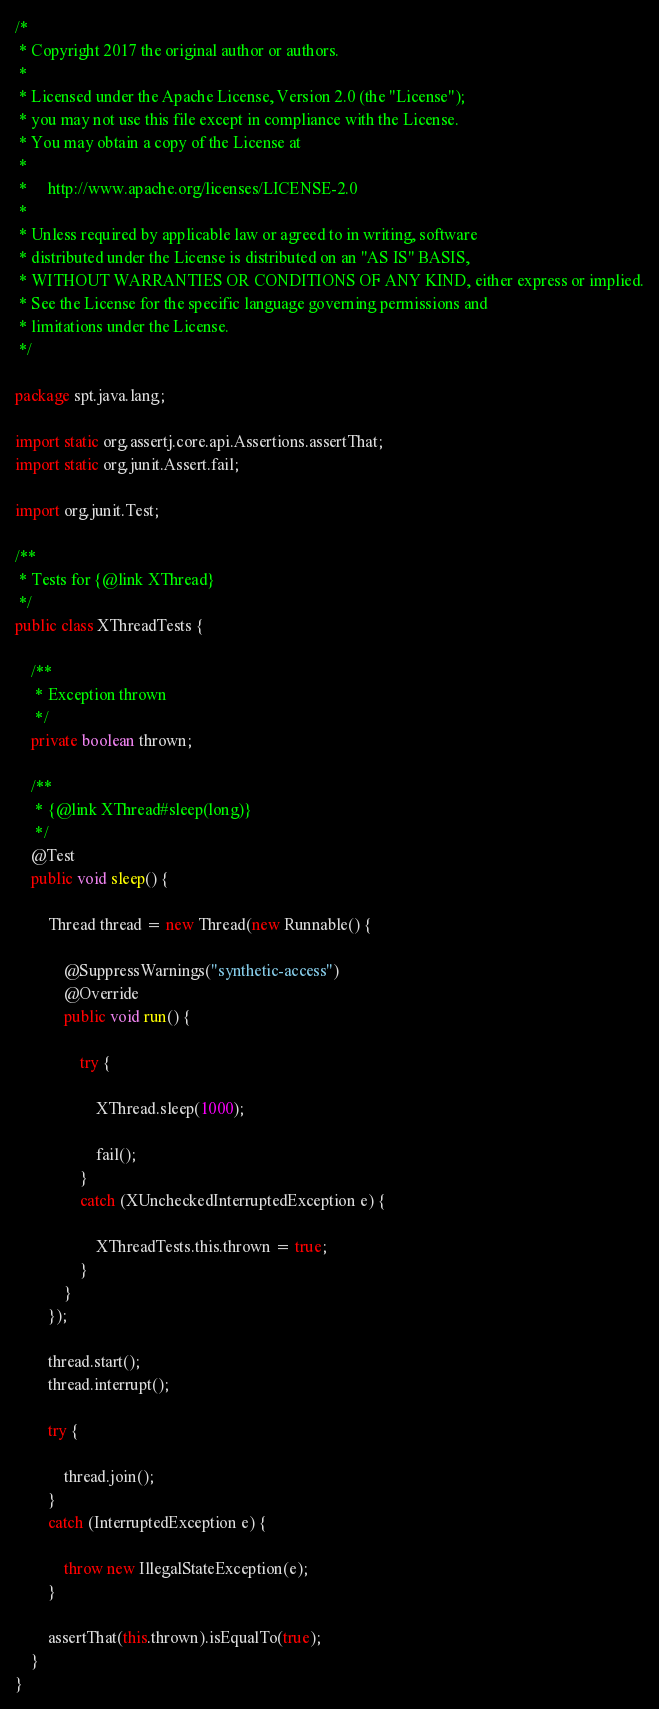<code> <loc_0><loc_0><loc_500><loc_500><_Java_>/*
 * Copyright 2017 the original author or authors.
 *
 * Licensed under the Apache License, Version 2.0 (the "License");
 * you may not use this file except in compliance with the License.
 * You may obtain a copy of the License at
 *
 *     http://www.apache.org/licenses/LICENSE-2.0
 *
 * Unless required by applicable law or agreed to in writing, software
 * distributed under the License is distributed on an "AS IS" BASIS,
 * WITHOUT WARRANTIES OR CONDITIONS OF ANY KIND, either express or implied.
 * See the License for the specific language governing permissions and
 * limitations under the License.
 */

package spt.java.lang;

import static org.assertj.core.api.Assertions.assertThat;
import static org.junit.Assert.fail;

import org.junit.Test;

/**
 * Tests for {@link XThread}
 */
public class XThreadTests {
	
	/**
	 * Exception thrown
	 */
	private boolean thrown;
	
	/**
	 * {@link XThread#sleep(long)}
	 */
	@Test
	public void sleep() {
		
		Thread thread = new Thread(new Runnable() {
			
			@SuppressWarnings("synthetic-access")
			@Override
			public void run() {
				
				try {
					
					XThread.sleep(1000);
					
					fail();
				}
				catch (XUncheckedInterruptedException e) {
					
					XThreadTests.this.thrown = true;
				}
			}
		});
		
		thread.start();
		thread.interrupt();
		
		try {
			
			thread.join();
		}
		catch (InterruptedException e) {
			
			throw new IllegalStateException(e);
		}
		
		assertThat(this.thrown).isEqualTo(true);
	}
}
</code> 